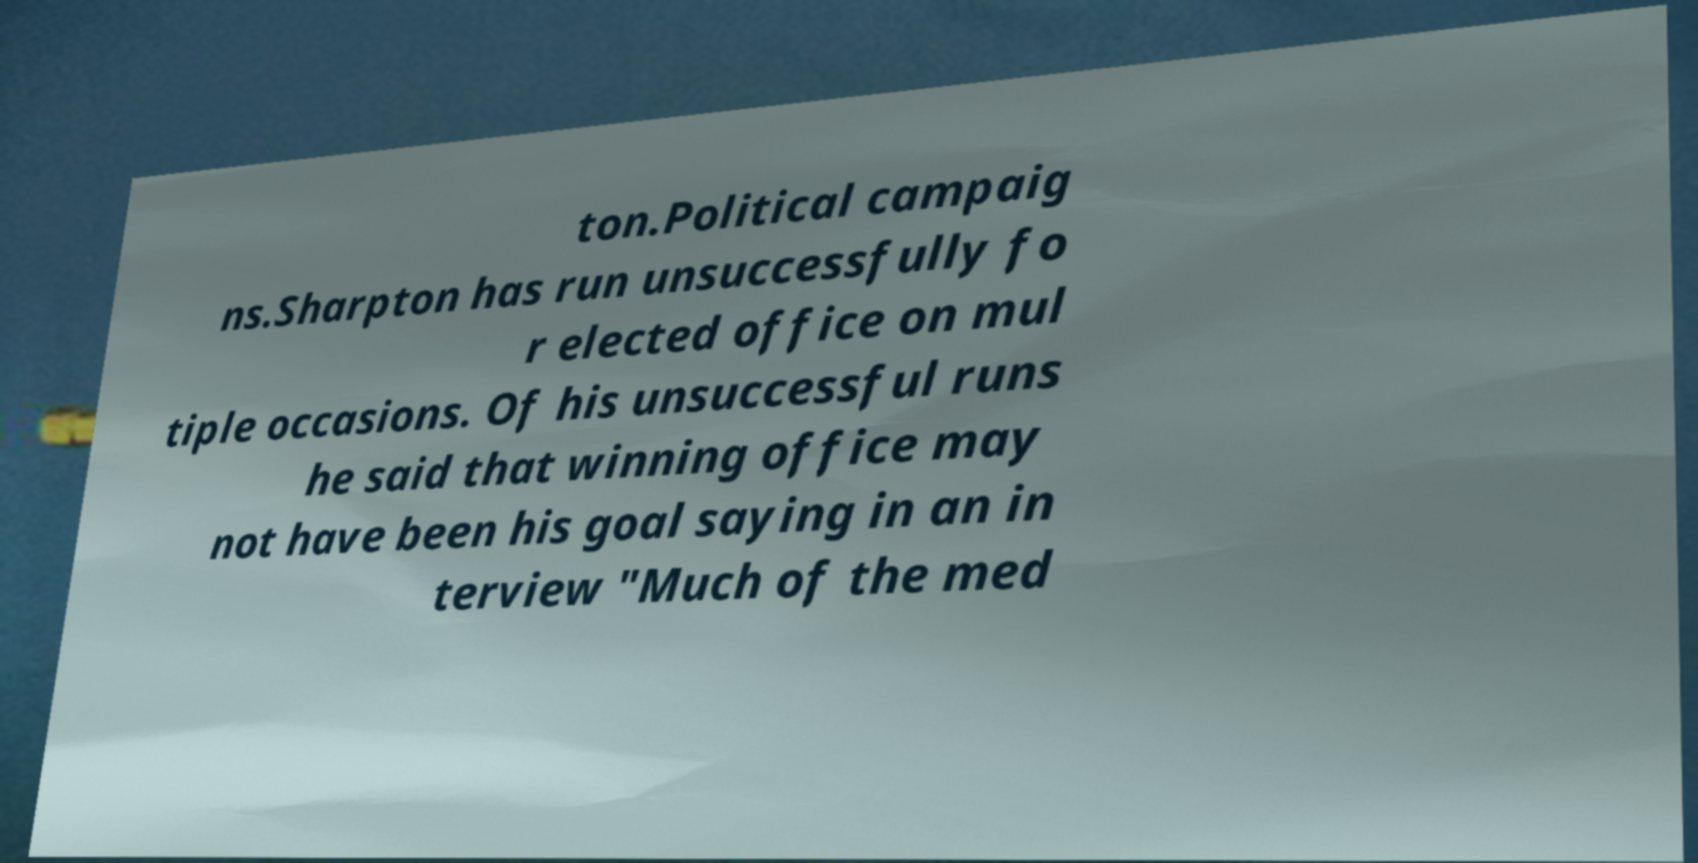Could you extract and type out the text from this image? ton.Political campaig ns.Sharpton has run unsuccessfully fo r elected office on mul tiple occasions. Of his unsuccessful runs he said that winning office may not have been his goal saying in an in terview "Much of the med 